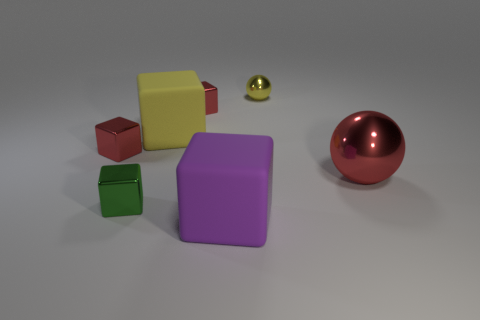There is a small sphere that is the same material as the green thing; what is its color?
Provide a short and direct response. Yellow. How many rubber things are the same size as the yellow rubber cube?
Ensure brevity in your answer.  1. There is a block that is in front of the green metallic block; is it the same size as the tiny shiny sphere?
Keep it short and to the point. No. What shape is the object that is right of the large purple block and behind the big red metallic thing?
Keep it short and to the point. Sphere. Are there any tiny green cubes behind the tiny yellow metallic ball?
Offer a terse response. No. Is there any other thing that has the same shape as the green object?
Your answer should be very brief. Yes. Is the shape of the yellow matte thing the same as the green thing?
Your answer should be compact. Yes. Are there an equal number of large rubber cubes that are left of the purple cube and purple cubes in front of the yellow cube?
Your answer should be compact. Yes. How many other things are the same material as the tiny green cube?
Your answer should be compact. 4. How many tiny things are shiny things or red shiny balls?
Provide a succinct answer. 4. 